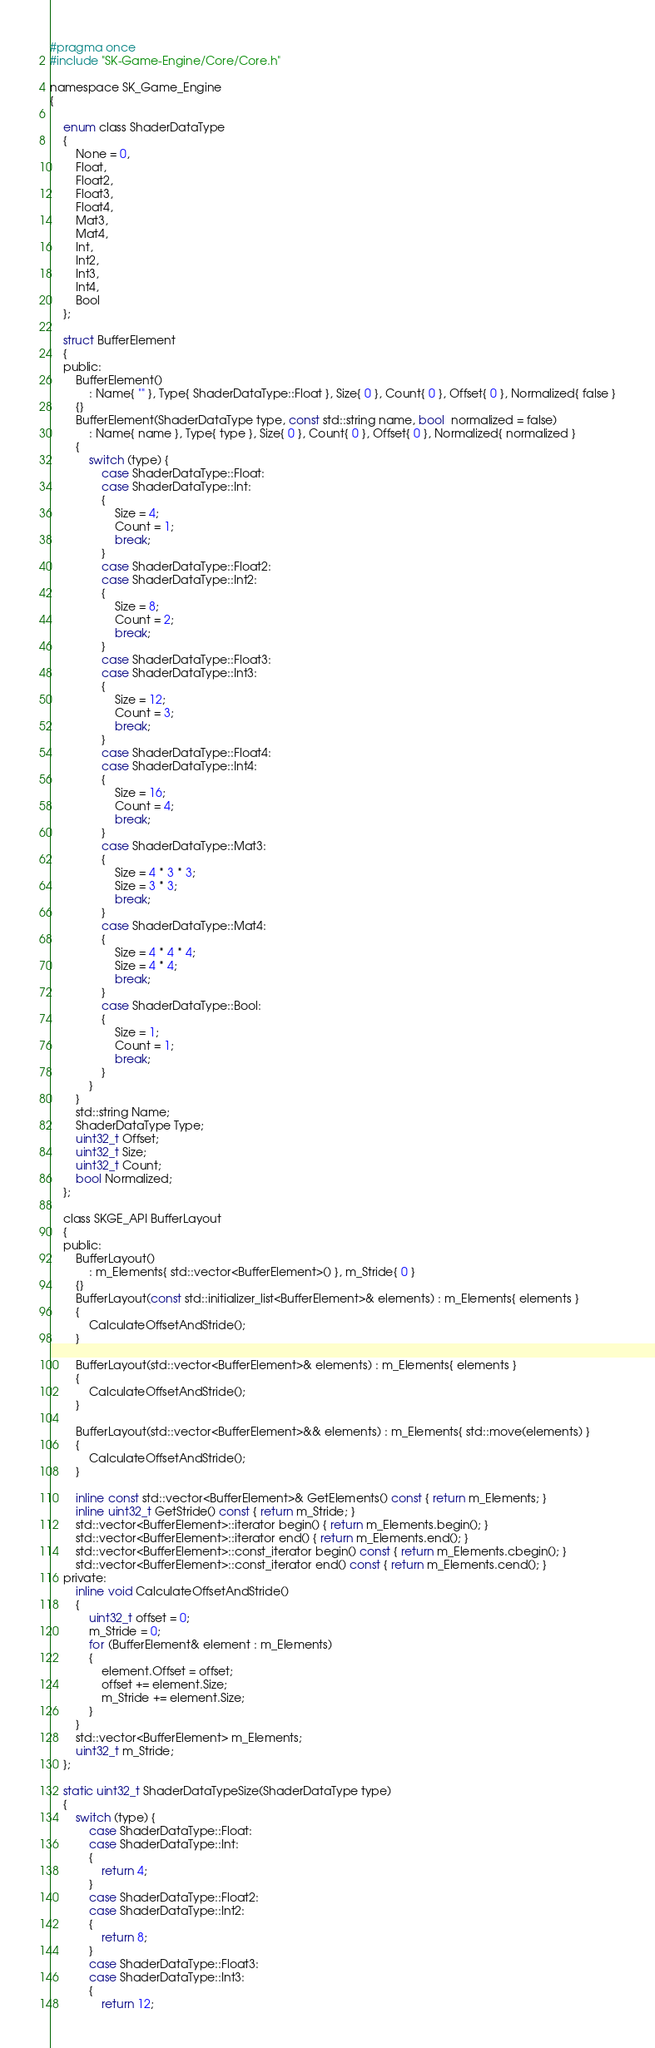<code> <loc_0><loc_0><loc_500><loc_500><_C_>#pragma once
#include "SK-Game-Engine/Core/Core.h"

namespace SK_Game_Engine
{

	enum class ShaderDataType
	{
		None = 0,
		Float,
		Float2,
		Float3,
		Float4,
		Mat3,
		Mat4,
		Int,
		Int2,
		Int3,
		Int4,
		Bool
	};

	struct BufferElement
	{
	public:
		BufferElement()
			: Name{ "" }, Type{ ShaderDataType::Float }, Size{ 0 }, Count{ 0 }, Offset{ 0 }, Normalized{ false }
		{}
		BufferElement(ShaderDataType type, const std::string name, bool  normalized = false)
			: Name{ name }, Type{ type }, Size{ 0 }, Count{ 0 }, Offset{ 0 }, Normalized{ normalized }
		{
			switch (type) {
				case ShaderDataType::Float:
				case ShaderDataType::Int:
				{
					Size = 4;
					Count = 1;
					break;
				}
				case ShaderDataType::Float2:
				case ShaderDataType::Int2:
				{
					Size = 8;
					Count = 2;
					break;
				}
				case ShaderDataType::Float3:
				case ShaderDataType::Int3:
				{
					Size = 12;
					Count = 3;
					break;
				}
				case ShaderDataType::Float4:
				case ShaderDataType::Int4:
				{
					Size = 16;
					Count = 4;
					break;
				}
				case ShaderDataType::Mat3:
				{
					Size = 4 * 3 * 3;
					Size = 3 * 3;
					break;
				}
				case ShaderDataType::Mat4:
				{
					Size = 4 * 4 * 4;
					Size = 4 * 4;
					break;
				}
				case ShaderDataType::Bool:
				{
					Size = 1;
					Count = 1;
					break;
				}
			}
		}
		std::string Name;
		ShaderDataType Type;
		uint32_t Offset;
		uint32_t Size;
		uint32_t Count;
		bool Normalized;
	};

	class SKGE_API BufferLayout
	{
	public:
		BufferLayout()
			: m_Elements{ std::vector<BufferElement>() }, m_Stride{ 0 }
		{}
		BufferLayout(const std::initializer_list<BufferElement>& elements) : m_Elements{ elements }
		{
			CalculateOffsetAndStride();
		}

		BufferLayout(std::vector<BufferElement>& elements) : m_Elements{ elements }
		{
			CalculateOffsetAndStride();
		}

		BufferLayout(std::vector<BufferElement>&& elements) : m_Elements{ std::move(elements) }
		{
			CalculateOffsetAndStride();
		}

		inline const std::vector<BufferElement>& GetElements() const { return m_Elements; }
		inline uint32_t GetStride() const { return m_Stride; }
		std::vector<BufferElement>::iterator begin() { return m_Elements.begin(); }
		std::vector<BufferElement>::iterator end() { return m_Elements.end(); }
		std::vector<BufferElement>::const_iterator begin() const { return m_Elements.cbegin(); }
		std::vector<BufferElement>::const_iterator end() const { return m_Elements.cend(); }
	private:
		inline void CalculateOffsetAndStride()
		{
			uint32_t offset = 0;
			m_Stride = 0;
			for (BufferElement& element : m_Elements)
			{
				element.Offset = offset;
				offset += element.Size;
				m_Stride += element.Size;
			}
		}
		std::vector<BufferElement> m_Elements;
		uint32_t m_Stride;
	};

	static uint32_t ShaderDataTypeSize(ShaderDataType type)
	{
		switch (type) {
			case ShaderDataType::Float:
			case ShaderDataType::Int:
			{
				return 4;
			}
			case ShaderDataType::Float2:
			case ShaderDataType::Int2:
			{
				return 8;
			}
			case ShaderDataType::Float3:
			case ShaderDataType::Int3:
			{
				return 12;</code> 